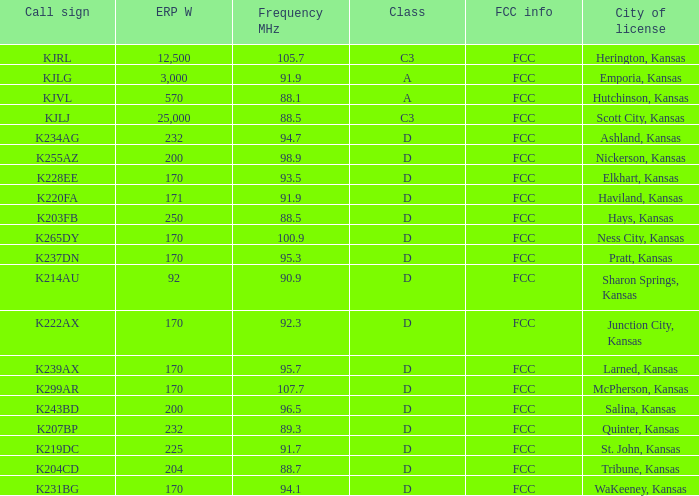ERP W that has a Class of d, and a Call sign of k299ar is what total number? 1.0. 